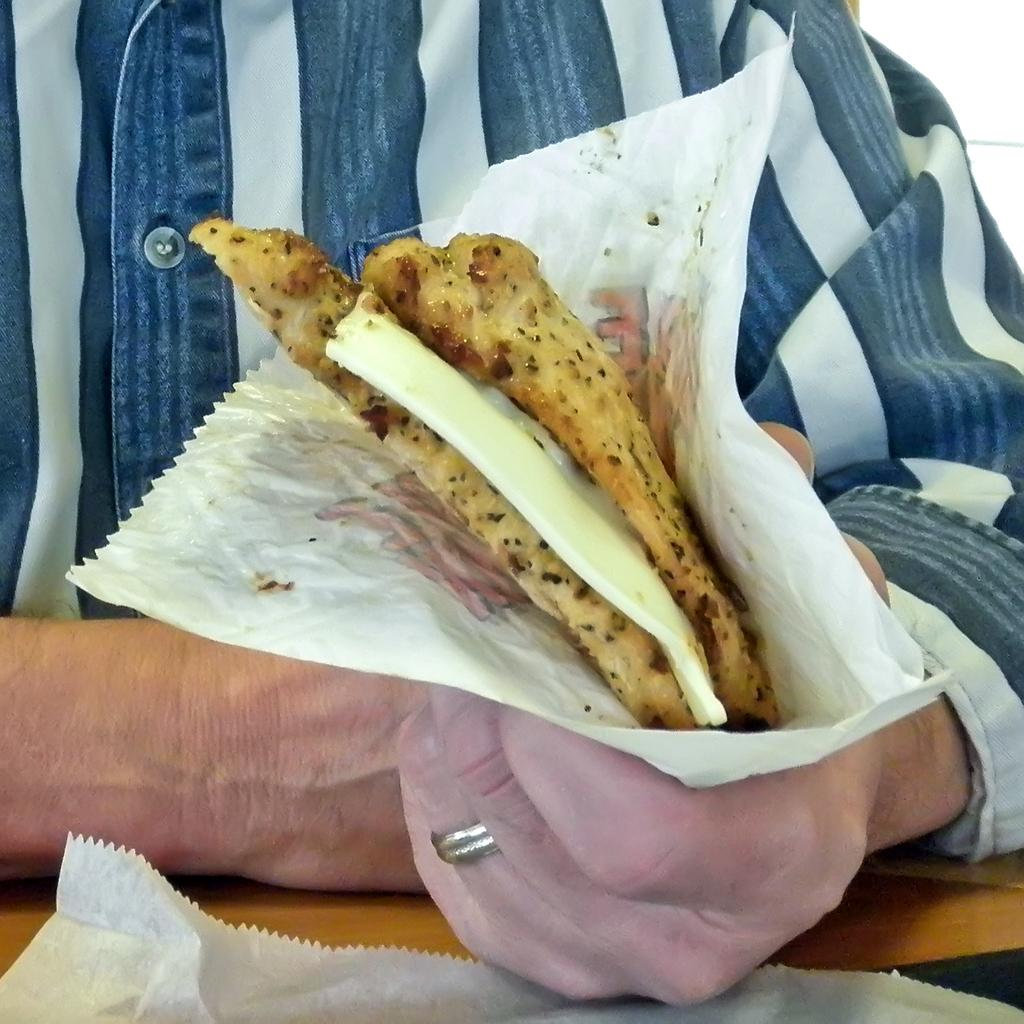What is the main subject of the image? There is a person in the image. What is the person holding in the image? The person is holding a food item with paper. What is present at the bottom of the image? There is a table at the bottom of the image. What else can be seen on the table? There is paper visible on the table. What type of zipper can be seen on the person's clothing in the image? There is no zipper visible on the person's clothing in the image. Can you tell me what kind of haircut the person has in the image? The image does not provide enough detail to determine the person's haircut. 